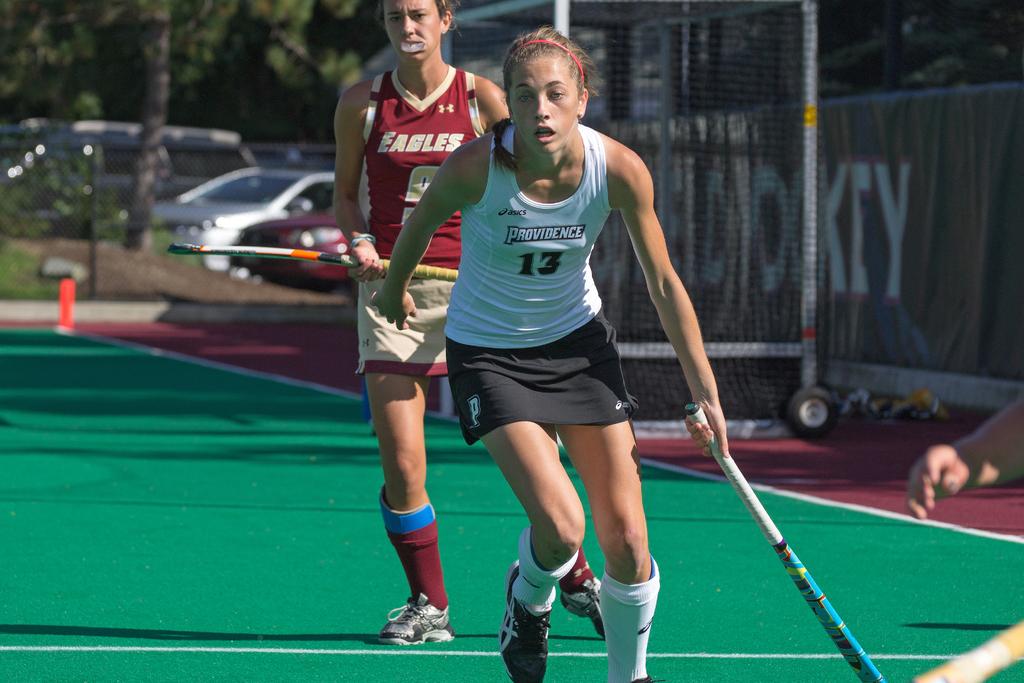Who are the two teams playing field hockey?
Your response must be concise. Eagles and providence. What is the girl's jersey number in the front?
Offer a terse response. 13. 